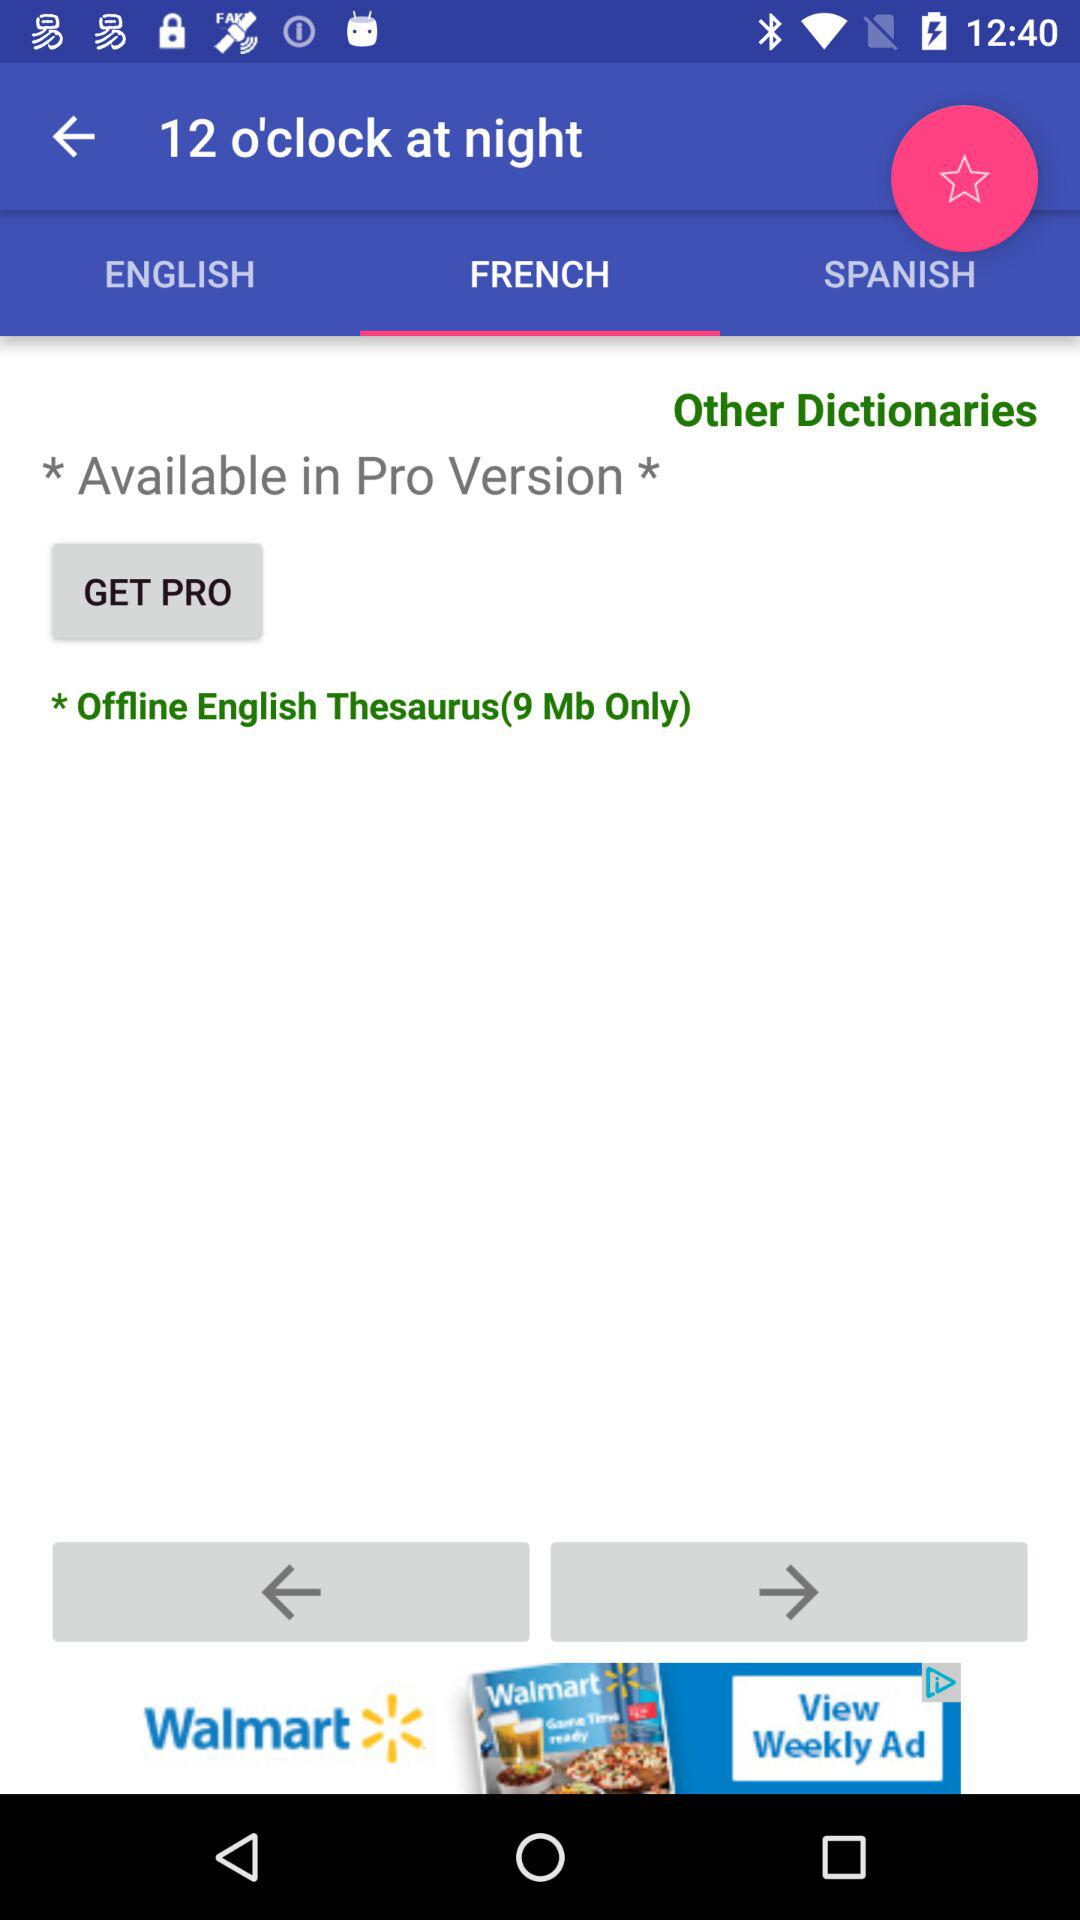How many languages are available for download?
Answer the question using a single word or phrase. 3 